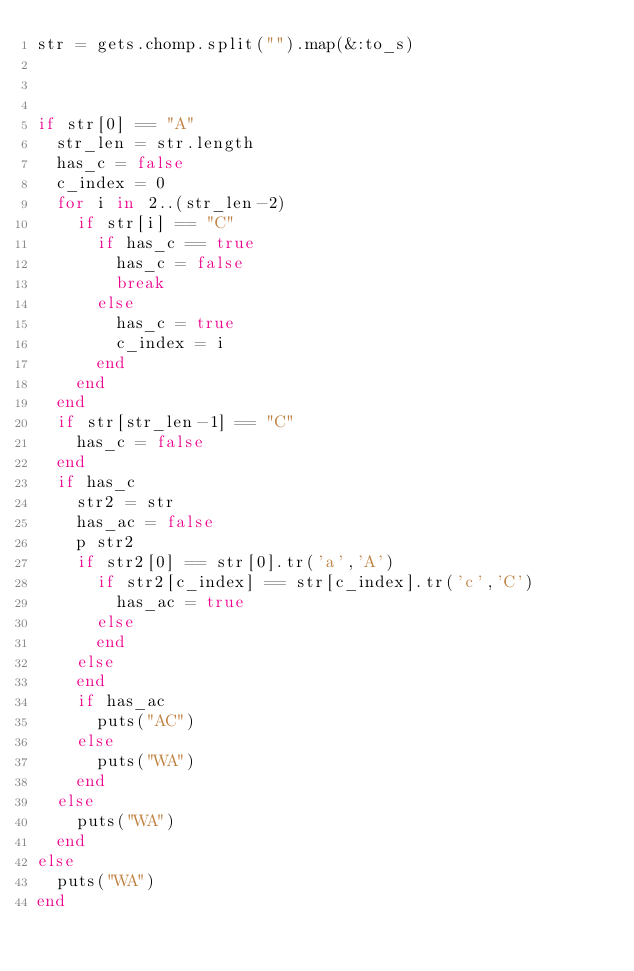<code> <loc_0><loc_0><loc_500><loc_500><_Ruby_>str = gets.chomp.split("").map(&:to_s)



if str[0] == "A"
  str_len = str.length
  has_c = false
  c_index = 0
  for i in 2..(str_len-2)
    if str[i] == "C"
      if has_c == true
        has_c = false
        break
      else
        has_c = true
        c_index = i
      end
    end
  end
  if str[str_len-1] == "C"
    has_c = false
  end
  if has_c
    str2 = str
    has_ac = false
    p str2
    if str2[0] == str[0].tr('a','A')
      if str2[c_index] == str[c_index].tr('c','C')
        has_ac = true
      else
      end
    else
    end
    if has_ac
      puts("AC")
    else
      puts("WA")
    end
  else
    puts("WA")
  end
else
  puts("WA")
end
</code> 